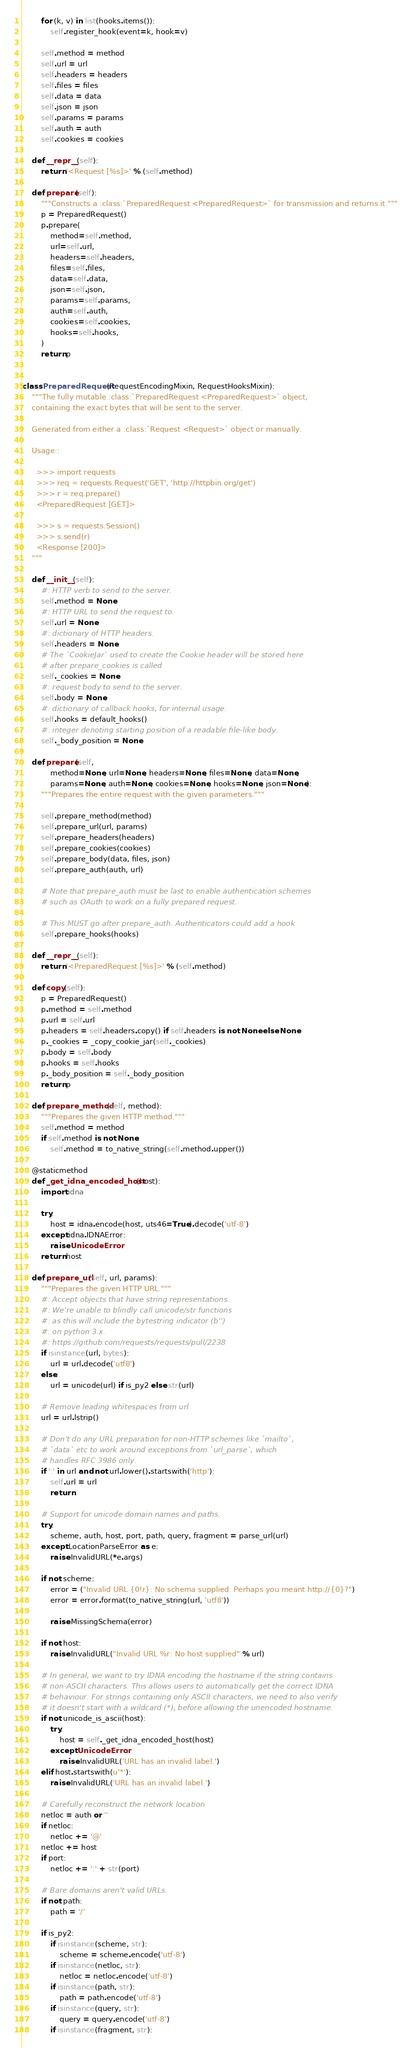<code> <loc_0><loc_0><loc_500><loc_500><_Python_>        for (k, v) in list(hooks.items()):
            self.register_hook(event=k, hook=v)

        self.method = method
        self.url = url
        self.headers = headers
        self.files = files
        self.data = data
        self.json = json
        self.params = params
        self.auth = auth
        self.cookies = cookies

    def __repr__(self):
        return '<Request [%s]>' % (self.method)

    def prepare(self):
        """Constructs a :class:`PreparedRequest <PreparedRequest>` for transmission and returns it."""
        p = PreparedRequest()
        p.prepare(
            method=self.method,
            url=self.url,
            headers=self.headers,
            files=self.files,
            data=self.data,
            json=self.json,
            params=self.params,
            auth=self.auth,
            cookies=self.cookies,
            hooks=self.hooks,
        )
        return p


class PreparedRequest(RequestEncodingMixin, RequestHooksMixin):
    """The fully mutable :class:`PreparedRequest <PreparedRequest>` object,
    containing the exact bytes that will be sent to the server.

    Generated from either a :class:`Request <Request>` object or manually.

    Usage::

      >>> import requests
      >>> req = requests.Request('GET', 'http://httpbin.org/get')
      >>> r = req.prepare()
      <PreparedRequest [GET]>

      >>> s = requests.Session()
      >>> s.send(r)
      <Response [200]>
    """

    def __init__(self):
        #: HTTP verb to send to the server.
        self.method = None
        #: HTTP URL to send the request to.
        self.url = None
        #: dictionary of HTTP headers.
        self.headers = None
        # The `CookieJar` used to create the Cookie header will be stored here
        # after prepare_cookies is called
        self._cookies = None
        #: request body to send to the server.
        self.body = None
        #: dictionary of callback hooks, for internal usage.
        self.hooks = default_hooks()
        #: integer denoting starting position of a readable file-like body.
        self._body_position = None

    def prepare(self,
            method=None, url=None, headers=None, files=None, data=None,
            params=None, auth=None, cookies=None, hooks=None, json=None):
        """Prepares the entire request with the given parameters."""

        self.prepare_method(method)
        self.prepare_url(url, params)
        self.prepare_headers(headers)
        self.prepare_cookies(cookies)
        self.prepare_body(data, files, json)
        self.prepare_auth(auth, url)

        # Note that prepare_auth must be last to enable authentication schemes
        # such as OAuth to work on a fully prepared request.

        # This MUST go after prepare_auth. Authenticators could add a hook
        self.prepare_hooks(hooks)

    def __repr__(self):
        return '<PreparedRequest [%s]>' % (self.method)

    def copy(self):
        p = PreparedRequest()
        p.method = self.method
        p.url = self.url
        p.headers = self.headers.copy() if self.headers is not None else None
        p._cookies = _copy_cookie_jar(self._cookies)
        p.body = self.body
        p.hooks = self.hooks
        p._body_position = self._body_position
        return p

    def prepare_method(self, method):
        """Prepares the given HTTP method."""
        self.method = method
        if self.method is not None:
            self.method = to_native_string(self.method.upper())

    @staticmethod
    def _get_idna_encoded_host(host):
        import idna

        try:
            host = idna.encode(host, uts46=True).decode('utf-8')
        except idna.IDNAError:
            raise UnicodeError
        return host

    def prepare_url(self, url, params):
        """Prepares the given HTTP URL."""
        #: Accept objects that have string representations.
        #: We're unable to blindly call unicode/str functions
        #: as this will include the bytestring indicator (b'')
        #: on python 3.x.
        #: https://github.com/requests/requests/pull/2238
        if isinstance(url, bytes):
            url = url.decode('utf8')
        else:
            url = unicode(url) if is_py2 else str(url)

        # Remove leading whitespaces from url
        url = url.lstrip()

        # Don't do any URL preparation for non-HTTP schemes like `mailto`,
        # `data` etc to work around exceptions from `url_parse`, which
        # handles RFC 3986 only.
        if ':' in url and not url.lower().startswith('http'):
            self.url = url
            return

        # Support for unicode domain names and paths.
        try:
            scheme, auth, host, port, path, query, fragment = parse_url(url)
        except LocationParseError as e:
            raise InvalidURL(*e.args)

        if not scheme:
            error = ("Invalid URL {0!r}: No schema supplied. Perhaps you meant http://{0}?")
            error = error.format(to_native_string(url, 'utf8'))

            raise MissingSchema(error)

        if not host:
            raise InvalidURL("Invalid URL %r: No host supplied" % url)

        # In general, we want to try IDNA encoding the hostname if the string contains
        # non-ASCII characters. This allows users to automatically get the correct IDNA
        # behaviour. For strings containing only ASCII characters, we need to also verify
        # it doesn't start with a wildcard (*), before allowing the unencoded hostname.
        if not unicode_is_ascii(host):
            try:
                host = self._get_idna_encoded_host(host)
            except UnicodeError:
                raise InvalidURL('URL has an invalid label.')
        elif host.startswith(u'*'):
            raise InvalidURL('URL has an invalid label.')

        # Carefully reconstruct the network location
        netloc = auth or ''
        if netloc:
            netloc += '@'
        netloc += host
        if port:
            netloc += ':' + str(port)

        # Bare domains aren't valid URLs.
        if not path:
            path = '/'

        if is_py2:
            if isinstance(scheme, str):
                scheme = scheme.encode('utf-8')
            if isinstance(netloc, str):
                netloc = netloc.encode('utf-8')
            if isinstance(path, str):
                path = path.encode('utf-8')
            if isinstance(query, str):
                query = query.encode('utf-8')
            if isinstance(fragment, str):</code> 